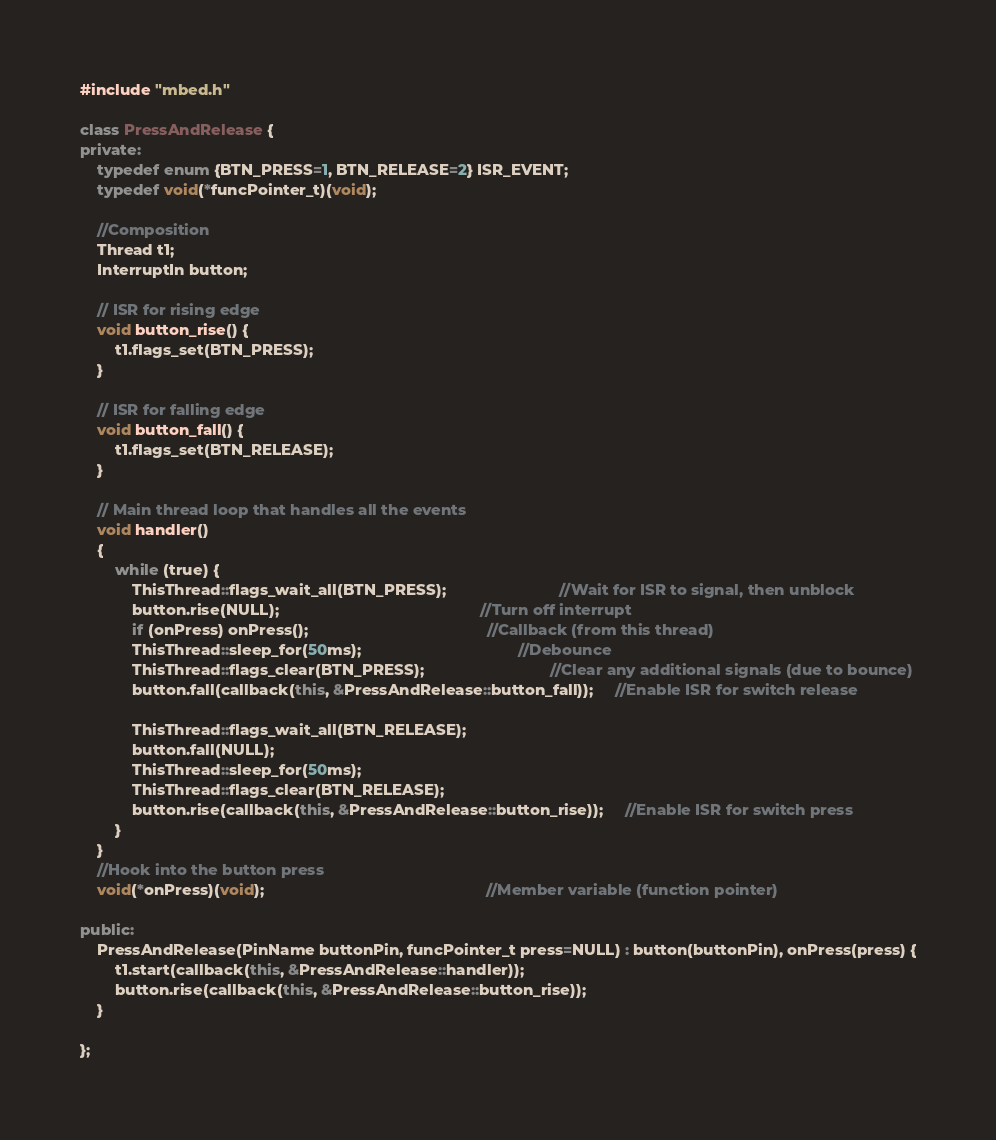Convert code to text. <code><loc_0><loc_0><loc_500><loc_500><_C++_>#include "mbed.h"

class PressAndRelease {
private:
    typedef enum {BTN_PRESS=1, BTN_RELEASE=2} ISR_EVENT;
    typedef void(*funcPointer_t)(void);
    
    //Composition
    Thread t1;                              
    InterruptIn button;                     

    // ISR for rising edge
    void button_rise() {
        t1.flags_set(BTN_PRESS);
    }

    // ISR for falling edge
    void button_fall() {
        t1.flags_set(BTN_RELEASE);    
    }

    // Main thread loop that handles all the events
    void handler() 
    {
        while (true) {
            ThisThread::flags_wait_all(BTN_PRESS);                          //Wait for ISR to signal, then unblock
            button.rise(NULL);                                              //Turn off interrupt 
            if (onPress) onPress();                                         //Callback (from this thread)
            ThisThread::sleep_for(50ms);                                    //Debounce
            ThisThread::flags_clear(BTN_PRESS);                             //Clear any additional signals (due to bounce)
            button.fall(callback(this, &PressAndRelease::button_fall));     //Enable ISR for switch release

            ThisThread::flags_wait_all(BTN_RELEASE);                    
            button.fall(NULL);
            ThisThread::sleep_for(50ms);
            ThisThread::flags_clear(BTN_RELEASE);
            button.rise(callback(this, &PressAndRelease::button_rise));     //Enable ISR for switch press
        }
    }
    //Hook into the button press
    void(*onPress)(void);                                                   //Member variable (function pointer)

public:
    PressAndRelease(PinName buttonPin, funcPointer_t press=NULL) : button(buttonPin), onPress(press) {
        t1.start(callback(this, &PressAndRelease::handler));
        button.rise(callback(this, &PressAndRelease::button_rise));  
    }

};

</code> 